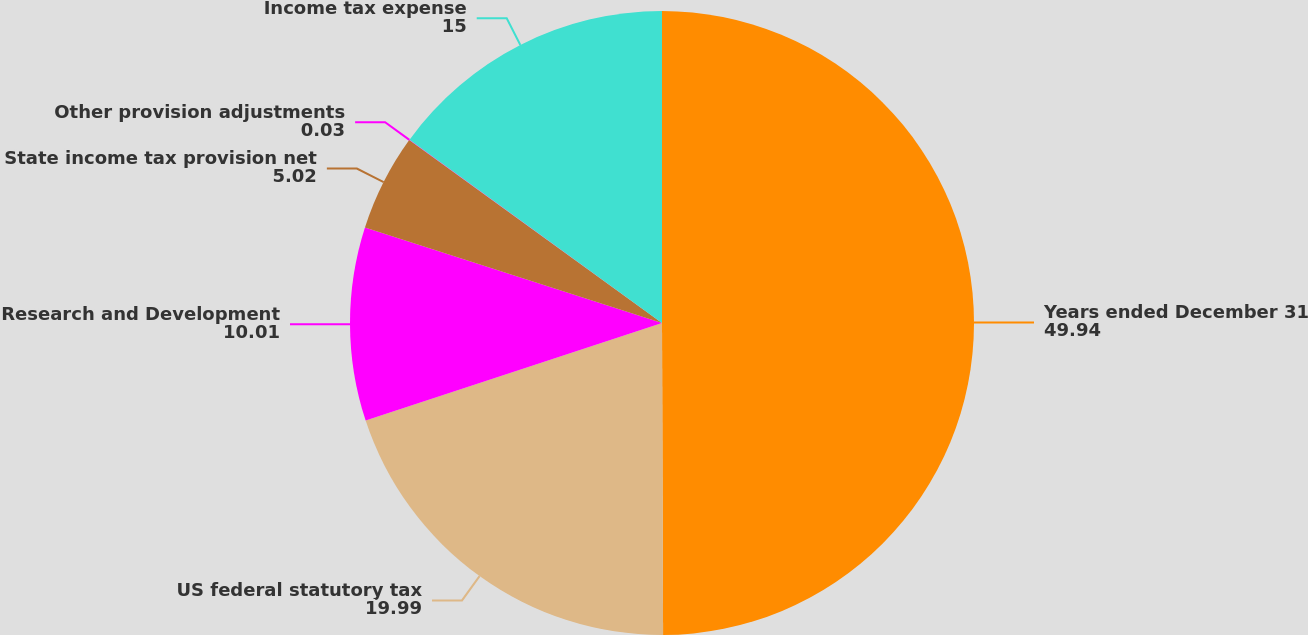<chart> <loc_0><loc_0><loc_500><loc_500><pie_chart><fcel>Years ended December 31<fcel>US federal statutory tax<fcel>Research and Development<fcel>State income tax provision net<fcel>Other provision adjustments<fcel>Income tax expense<nl><fcel>49.94%<fcel>19.99%<fcel>10.01%<fcel>5.02%<fcel>0.03%<fcel>15.0%<nl></chart> 